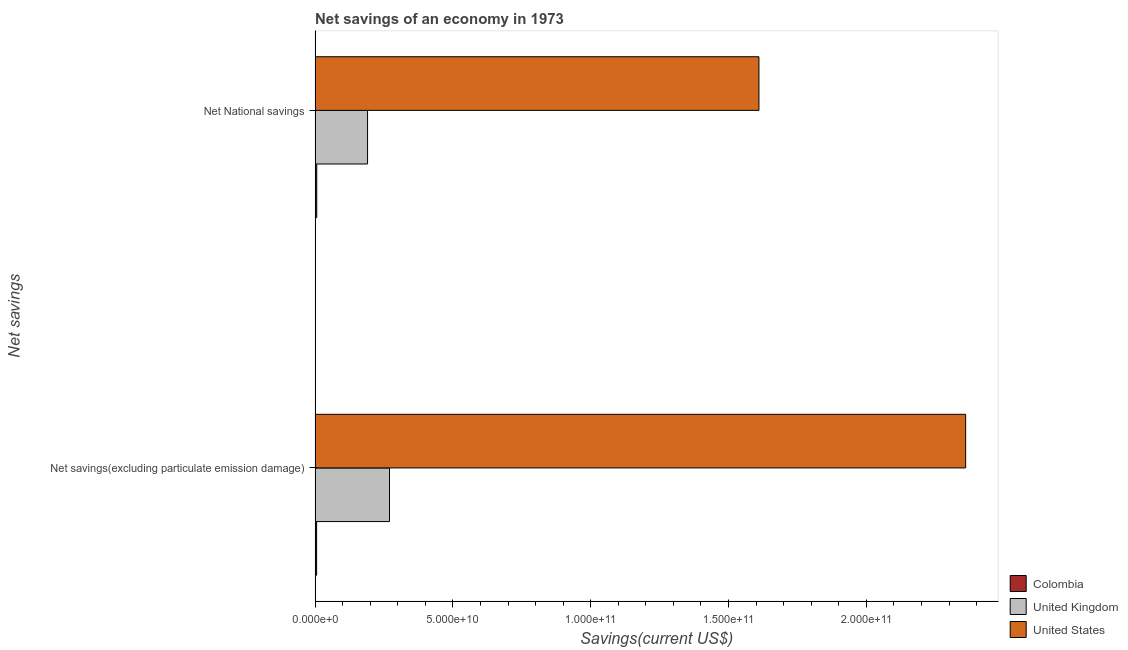How many bars are there on the 2nd tick from the top?
Offer a terse response. 3. How many bars are there on the 2nd tick from the bottom?
Offer a very short reply. 3. What is the label of the 2nd group of bars from the top?
Your answer should be very brief. Net savings(excluding particulate emission damage). What is the net savings(excluding particulate emission damage) in United Kingdom?
Ensure brevity in your answer.  2.70e+1. Across all countries, what is the maximum net national savings?
Keep it short and to the point. 1.61e+11. Across all countries, what is the minimum net savings(excluding particulate emission damage)?
Offer a terse response. 5.45e+08. What is the total net national savings in the graph?
Provide a succinct answer. 1.81e+11. What is the difference between the net savings(excluding particulate emission damage) in Colombia and that in United States?
Ensure brevity in your answer.  -2.35e+11. What is the difference between the net savings(excluding particulate emission damage) in United Kingdom and the net national savings in United States?
Ensure brevity in your answer.  -1.34e+11. What is the average net savings(excluding particulate emission damage) per country?
Provide a succinct answer. 8.79e+1. What is the difference between the net national savings and net savings(excluding particulate emission damage) in United Kingdom?
Ensure brevity in your answer.  -7.96e+09. In how many countries, is the net savings(excluding particulate emission damage) greater than 110000000000 US$?
Provide a succinct answer. 1. What is the ratio of the net savings(excluding particulate emission damage) in Colombia to that in United States?
Your answer should be very brief. 0. Is the net savings(excluding particulate emission damage) in United States less than that in United Kingdom?
Ensure brevity in your answer.  No. In how many countries, is the net national savings greater than the average net national savings taken over all countries?
Keep it short and to the point. 1. What does the 2nd bar from the bottom in Net National savings represents?
Keep it short and to the point. United Kingdom. How many bars are there?
Your response must be concise. 6. How many countries are there in the graph?
Give a very brief answer. 3. Are the values on the major ticks of X-axis written in scientific E-notation?
Provide a succinct answer. Yes. Does the graph contain any zero values?
Keep it short and to the point. No. How many legend labels are there?
Give a very brief answer. 3. How are the legend labels stacked?
Provide a succinct answer. Vertical. What is the title of the graph?
Offer a terse response. Net savings of an economy in 1973. What is the label or title of the X-axis?
Your answer should be compact. Savings(current US$). What is the label or title of the Y-axis?
Provide a short and direct response. Net savings. What is the Savings(current US$) in Colombia in Net savings(excluding particulate emission damage)?
Offer a terse response. 5.45e+08. What is the Savings(current US$) of United Kingdom in Net savings(excluding particulate emission damage)?
Your response must be concise. 2.70e+1. What is the Savings(current US$) in United States in Net savings(excluding particulate emission damage)?
Offer a very short reply. 2.36e+11. What is the Savings(current US$) of Colombia in Net National savings?
Ensure brevity in your answer.  5.98e+08. What is the Savings(current US$) of United Kingdom in Net National savings?
Provide a short and direct response. 1.90e+1. What is the Savings(current US$) of United States in Net National savings?
Your answer should be very brief. 1.61e+11. Across all Net savings, what is the maximum Savings(current US$) in Colombia?
Your response must be concise. 5.98e+08. Across all Net savings, what is the maximum Savings(current US$) of United Kingdom?
Your response must be concise. 2.70e+1. Across all Net savings, what is the maximum Savings(current US$) in United States?
Make the answer very short. 2.36e+11. Across all Net savings, what is the minimum Savings(current US$) of Colombia?
Your response must be concise. 5.45e+08. Across all Net savings, what is the minimum Savings(current US$) of United Kingdom?
Offer a very short reply. 1.90e+1. Across all Net savings, what is the minimum Savings(current US$) of United States?
Offer a very short reply. 1.61e+11. What is the total Savings(current US$) of Colombia in the graph?
Your response must be concise. 1.14e+09. What is the total Savings(current US$) in United Kingdom in the graph?
Offer a terse response. 4.60e+1. What is the total Savings(current US$) of United States in the graph?
Make the answer very short. 3.97e+11. What is the difference between the Savings(current US$) in Colombia in Net savings(excluding particulate emission damage) and that in Net National savings?
Keep it short and to the point. -5.36e+07. What is the difference between the Savings(current US$) in United Kingdom in Net savings(excluding particulate emission damage) and that in Net National savings?
Give a very brief answer. 7.96e+09. What is the difference between the Savings(current US$) of United States in Net savings(excluding particulate emission damage) and that in Net National savings?
Provide a succinct answer. 7.50e+1. What is the difference between the Savings(current US$) in Colombia in Net savings(excluding particulate emission damage) and the Savings(current US$) in United Kingdom in Net National savings?
Ensure brevity in your answer.  -1.85e+1. What is the difference between the Savings(current US$) in Colombia in Net savings(excluding particulate emission damage) and the Savings(current US$) in United States in Net National savings?
Provide a short and direct response. -1.60e+11. What is the difference between the Savings(current US$) of United Kingdom in Net savings(excluding particulate emission damage) and the Savings(current US$) of United States in Net National savings?
Offer a terse response. -1.34e+11. What is the average Savings(current US$) of Colombia per Net savings?
Provide a short and direct response. 5.72e+08. What is the average Savings(current US$) of United Kingdom per Net savings?
Keep it short and to the point. 2.30e+1. What is the average Savings(current US$) in United States per Net savings?
Your answer should be compact. 1.99e+11. What is the difference between the Savings(current US$) in Colombia and Savings(current US$) in United Kingdom in Net savings(excluding particulate emission damage)?
Provide a succinct answer. -2.65e+1. What is the difference between the Savings(current US$) in Colombia and Savings(current US$) in United States in Net savings(excluding particulate emission damage)?
Ensure brevity in your answer.  -2.35e+11. What is the difference between the Savings(current US$) of United Kingdom and Savings(current US$) of United States in Net savings(excluding particulate emission damage)?
Offer a very short reply. -2.09e+11. What is the difference between the Savings(current US$) in Colombia and Savings(current US$) in United Kingdom in Net National savings?
Give a very brief answer. -1.84e+1. What is the difference between the Savings(current US$) of Colombia and Savings(current US$) of United States in Net National savings?
Your answer should be compact. -1.60e+11. What is the difference between the Savings(current US$) in United Kingdom and Savings(current US$) in United States in Net National savings?
Offer a very short reply. -1.42e+11. What is the ratio of the Savings(current US$) of Colombia in Net savings(excluding particulate emission damage) to that in Net National savings?
Ensure brevity in your answer.  0.91. What is the ratio of the Savings(current US$) of United Kingdom in Net savings(excluding particulate emission damage) to that in Net National savings?
Your response must be concise. 1.42. What is the ratio of the Savings(current US$) in United States in Net savings(excluding particulate emission damage) to that in Net National savings?
Make the answer very short. 1.47. What is the difference between the highest and the second highest Savings(current US$) in Colombia?
Give a very brief answer. 5.36e+07. What is the difference between the highest and the second highest Savings(current US$) of United Kingdom?
Your response must be concise. 7.96e+09. What is the difference between the highest and the second highest Savings(current US$) of United States?
Your response must be concise. 7.50e+1. What is the difference between the highest and the lowest Savings(current US$) in Colombia?
Provide a succinct answer. 5.36e+07. What is the difference between the highest and the lowest Savings(current US$) in United Kingdom?
Your response must be concise. 7.96e+09. What is the difference between the highest and the lowest Savings(current US$) in United States?
Keep it short and to the point. 7.50e+1. 